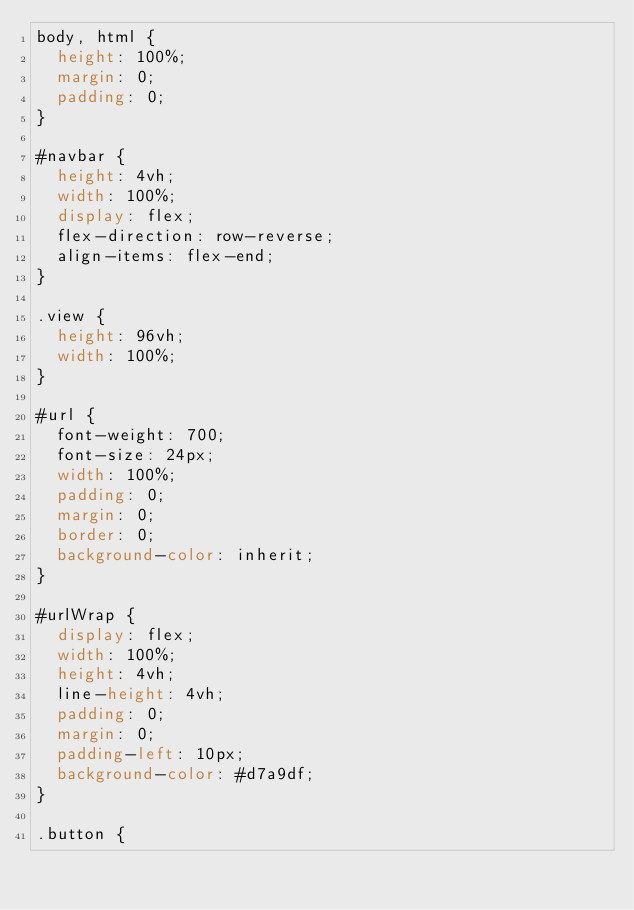Convert code to text. <code><loc_0><loc_0><loc_500><loc_500><_CSS_>body, html {
  height: 100%;
  margin: 0;
  padding: 0;
}

#navbar {
  height: 4vh;
  width: 100%;
  display: flex;
  flex-direction: row-reverse;
  align-items: flex-end;
}

.view {
  height: 96vh;
  width: 100%;
}

#url {
  font-weight: 700;
  font-size: 24px;
  width: 100%;
  padding: 0;
  margin: 0;
  border: 0;
  background-color: inherit;
}

#urlWrap {
  display: flex;
  width: 100%;
  height: 4vh;
  line-height: 4vh;
  padding: 0;
  margin: 0;
  padding-left: 10px;
  background-color: #d7a9df;
}

.button {</code> 